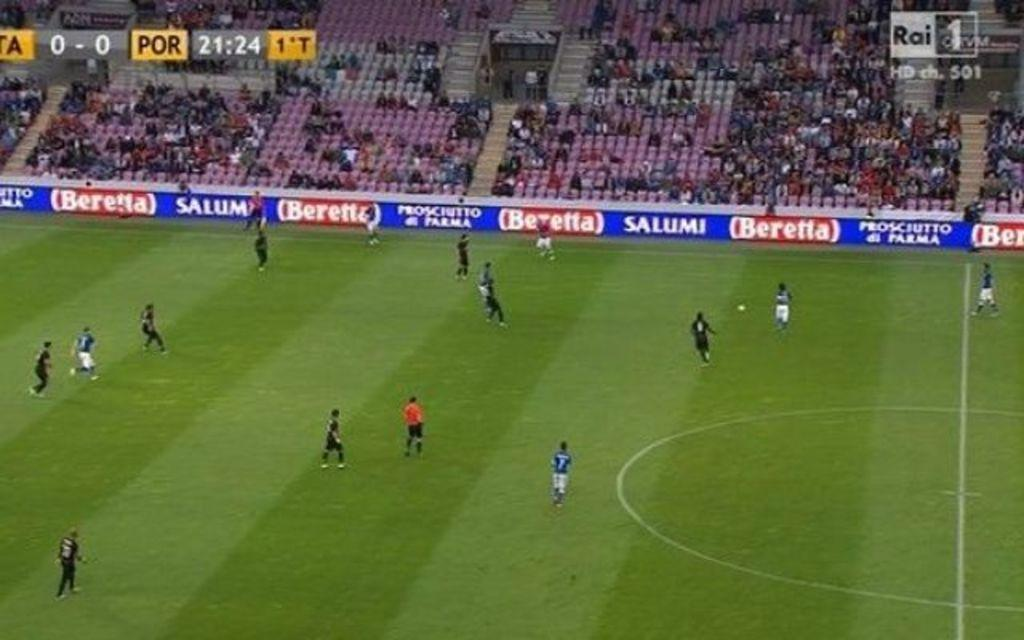<image>
Present a compact description of the photo's key features. Two soccer teams are on a field with Beretta advertised on signage. 